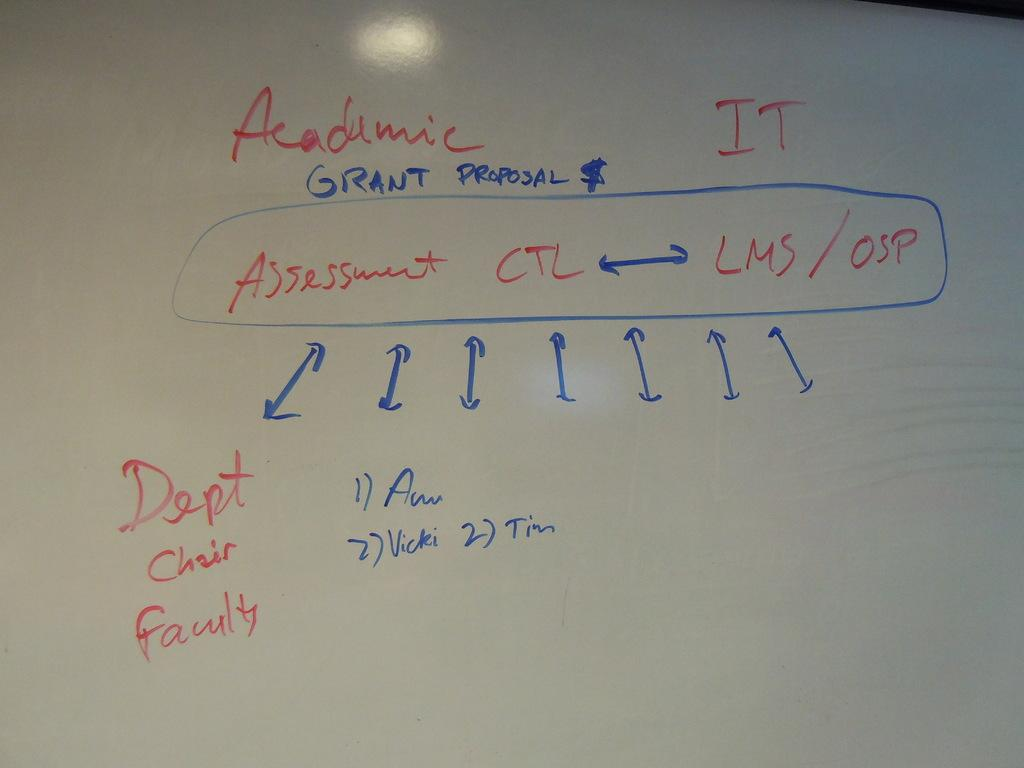<image>
Summarize the visual content of the image. White board which says the word "Academic" in red on top. 